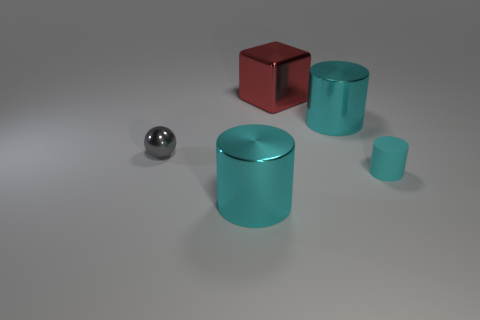What can you infer about the lighting of this scene? The uniform shadows cast by the objects and the diffused light on their surfaces suggest a soft, indirect lighting environment. There's likely a large, diffuse light source above the scene, providing even illumination with a gentle gradient, which is typical in controlled, studio-like settings. Could you estimate the time of the day this represents if it were outdoors? If this scene were outdoors, the soft shadows and diffused lighting would be indicative of an overcast day, where the clouds act as a natural diffuser for the sunlight. However, without additional context such as a sky or environmental features, it's difficult to determine an exact time of day. 